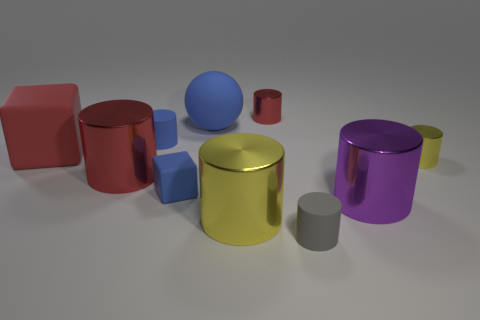Subtract 4 cylinders. How many cylinders are left? 3 Subtract all blue cylinders. How many cylinders are left? 6 Subtract all big purple metallic cylinders. How many cylinders are left? 6 Subtract all brown cylinders. Subtract all purple spheres. How many cylinders are left? 7 Subtract all cubes. How many objects are left? 8 Add 5 big yellow metallic things. How many big yellow metallic things exist? 6 Subtract 1 red blocks. How many objects are left? 9 Subtract all big purple cylinders. Subtract all big rubber spheres. How many objects are left? 8 Add 5 gray objects. How many gray objects are left? 6 